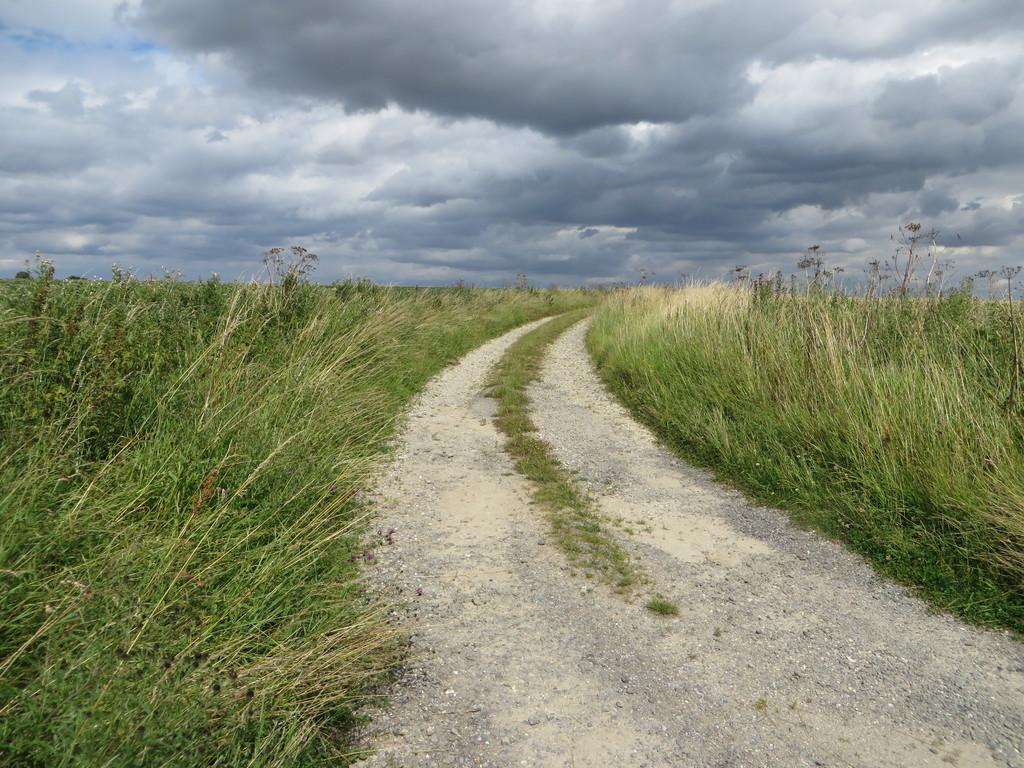What is the main feature in the middle of the image? There is a path or way in the middle of the image. What type of vegetation is present on either side of the path? There is grass on either side of the path. What is visible at the top of the image? The sky is visible at the top of the image. What can be observed in the sky? Clouds are present in the sky. What type of education is being offered to the body in the image? There is no body or education present in the image; it features a path, grass, sky, and clouds. 